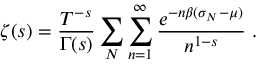<formula> <loc_0><loc_0><loc_500><loc_500>\zeta ( s ) = \frac { T ^ { - s } } { \Gamma ( s ) } \sum _ { N } \sum _ { n = 1 } ^ { \infty } \frac { e ^ { - n \beta ( \sigma _ { N } - \mu ) } } { n ^ { 1 - s } } \, .</formula> 